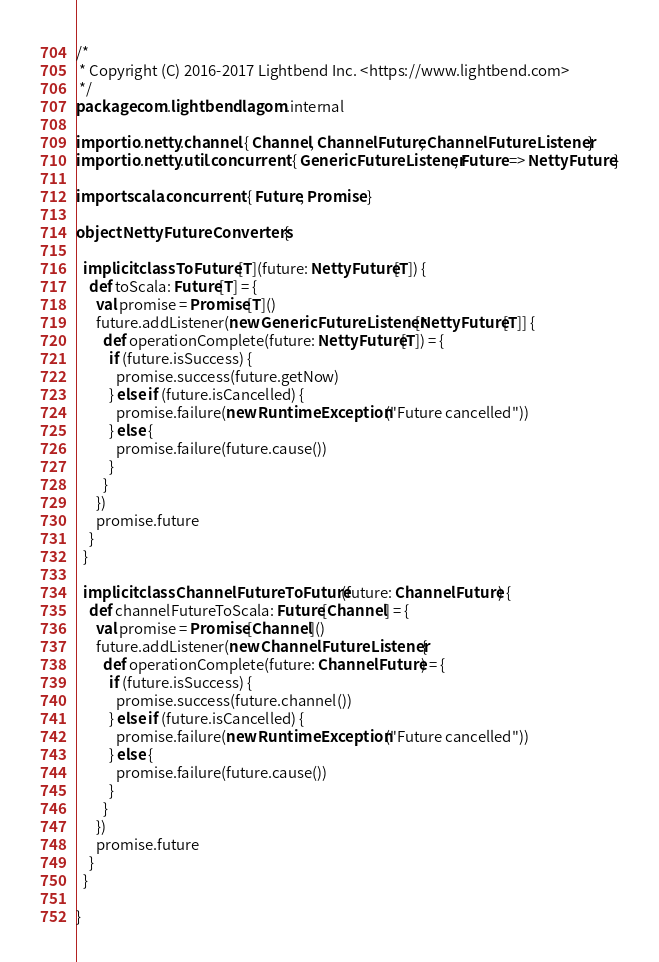Convert code to text. <code><loc_0><loc_0><loc_500><loc_500><_Scala_>/*
 * Copyright (C) 2016-2017 Lightbend Inc. <https://www.lightbend.com>
 */
package com.lightbend.lagom.internal

import io.netty.channel.{ Channel, ChannelFuture, ChannelFutureListener }
import io.netty.util.concurrent.{ GenericFutureListener, Future => NettyFuture }

import scala.concurrent.{ Future, Promise }

object NettyFutureConverters {

  implicit class ToFuture[T](future: NettyFuture[T]) {
    def toScala: Future[T] = {
      val promise = Promise[T]()
      future.addListener(new GenericFutureListener[NettyFuture[T]] {
        def operationComplete(future: NettyFuture[T]) = {
          if (future.isSuccess) {
            promise.success(future.getNow)
          } else if (future.isCancelled) {
            promise.failure(new RuntimeException("Future cancelled"))
          } else {
            promise.failure(future.cause())
          }
        }
      })
      promise.future
    }
  }

  implicit class ChannelFutureToFuture(future: ChannelFuture) {
    def channelFutureToScala: Future[Channel] = {
      val promise = Promise[Channel]()
      future.addListener(new ChannelFutureListener {
        def operationComplete(future: ChannelFuture) = {
          if (future.isSuccess) {
            promise.success(future.channel())
          } else if (future.isCancelled) {
            promise.failure(new RuntimeException("Future cancelled"))
          } else {
            promise.failure(future.cause())
          }
        }
      })
      promise.future
    }
  }

}
</code> 